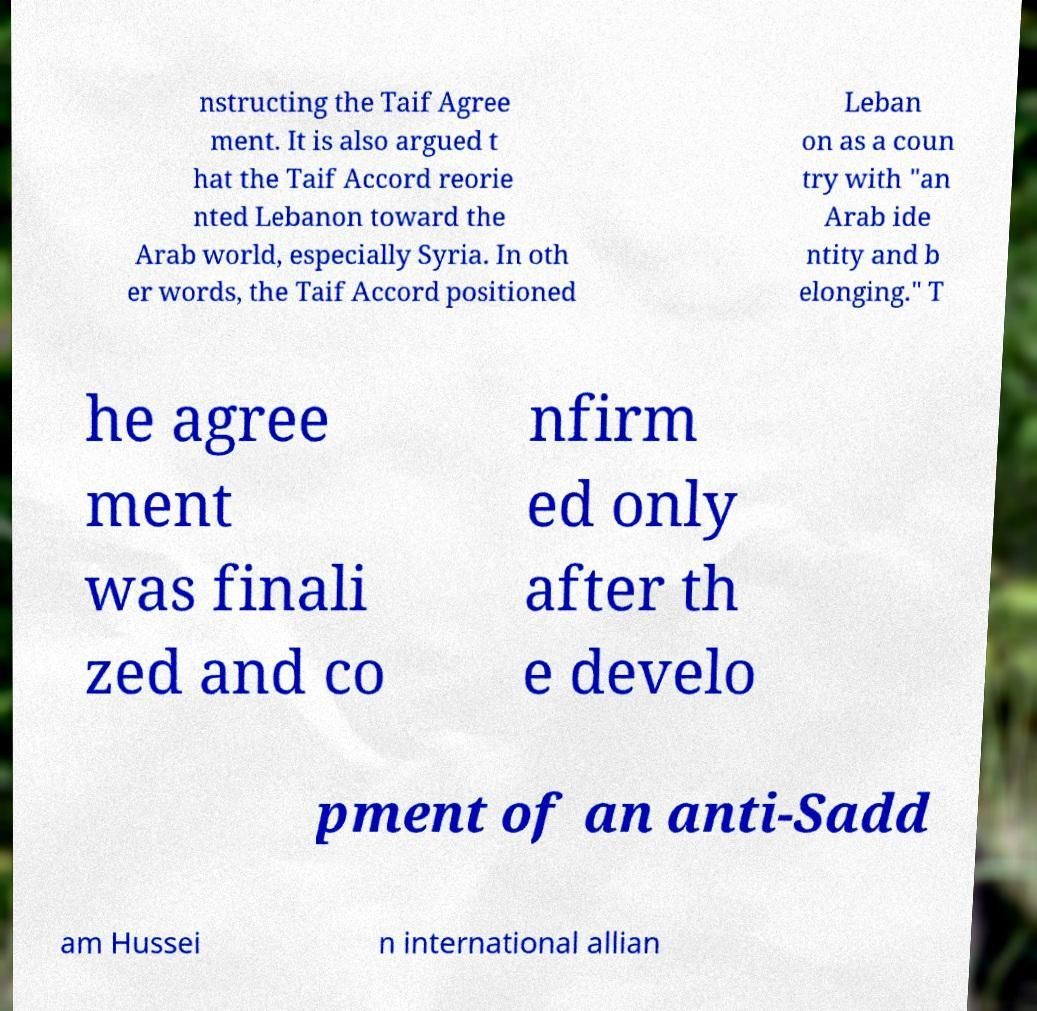Please identify and transcribe the text found in this image. nstructing the Taif Agree ment. It is also argued t hat the Taif Accord reorie nted Lebanon toward the Arab world, especially Syria. In oth er words, the Taif Accord positioned Leban on as a coun try with "an Arab ide ntity and b elonging." T he agree ment was finali zed and co nfirm ed only after th e develo pment of an anti-Sadd am Hussei n international allian 